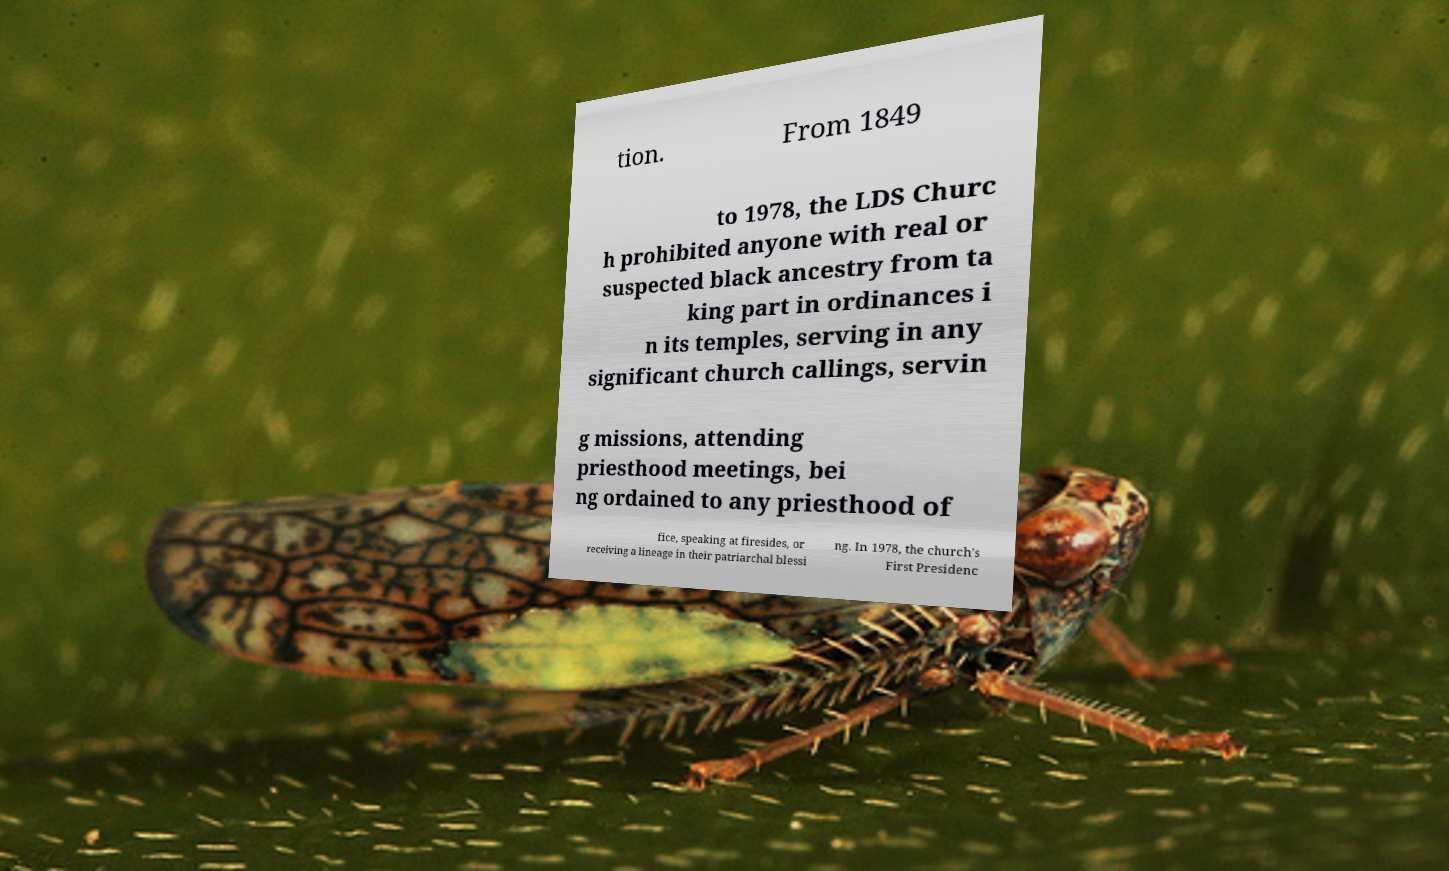For documentation purposes, I need the text within this image transcribed. Could you provide that? tion. From 1849 to 1978, the LDS Churc h prohibited anyone with real or suspected black ancestry from ta king part in ordinances i n its temples, serving in any significant church callings, servin g missions, attending priesthood meetings, bei ng ordained to any priesthood of fice, speaking at firesides, or receiving a lineage in their patriarchal blessi ng. In 1978, the church's First Presidenc 